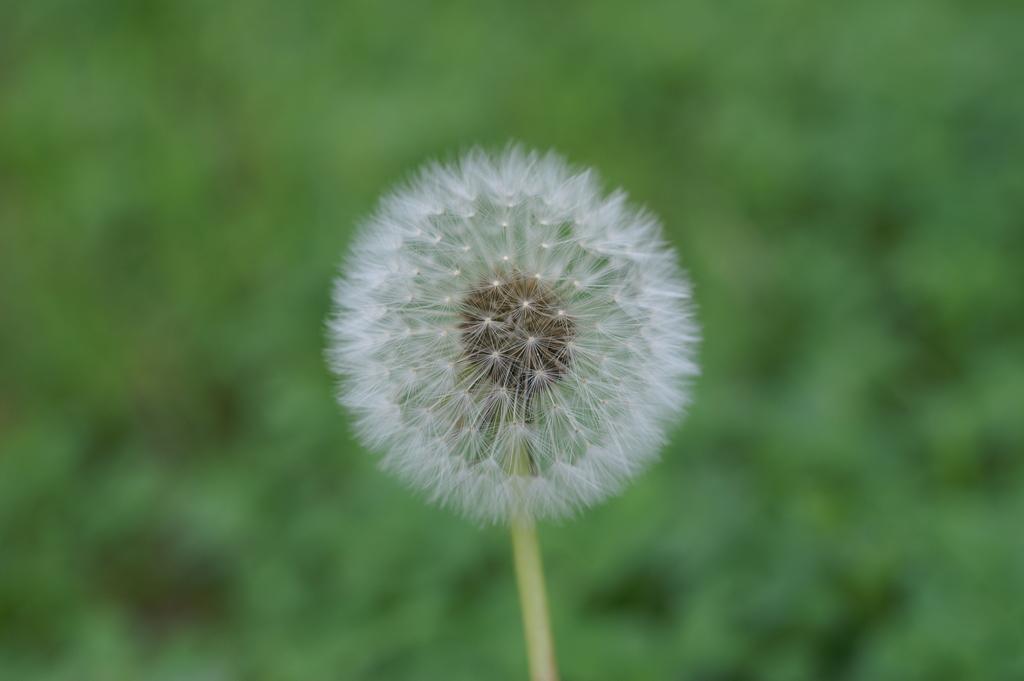Could you give a brief overview of what you see in this image? In this picture we can observe a white color flower. The background is in green color which is completely blurred. 